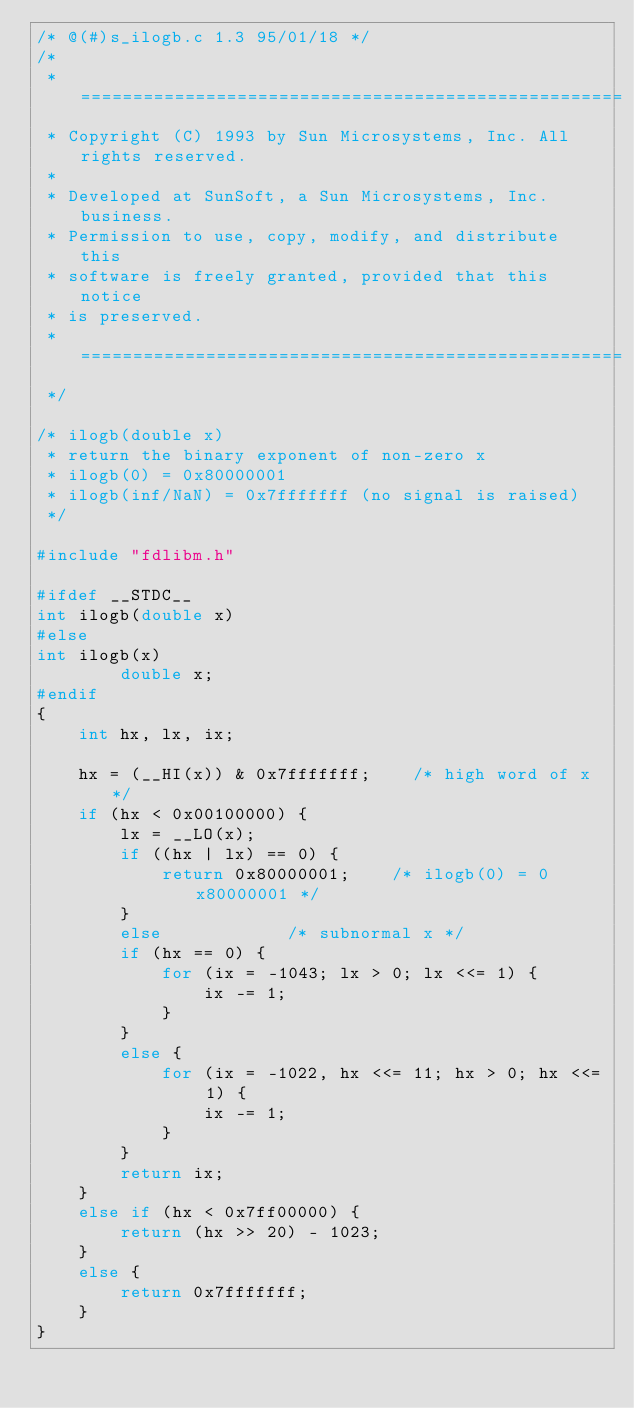Convert code to text. <code><loc_0><loc_0><loc_500><loc_500><_C_>/* @(#)s_ilogb.c 1.3 95/01/18 */
/*
 * ====================================================
 * Copyright (C) 1993 by Sun Microsystems, Inc. All rights reserved.
 *
 * Developed at SunSoft, a Sun Microsystems, Inc. business.
 * Permission to use, copy, modify, and distribute this
 * software is freely granted, provided that this notice 
 * is preserved.
 * ====================================================
 */

/* ilogb(double x)
 * return the binary exponent of non-zero x
 * ilogb(0) = 0x80000001
 * ilogb(inf/NaN) = 0x7fffffff (no signal is raised)
 */

#include "fdlibm.h"

#ifdef __STDC__
int ilogb(double x)
#else
int ilogb(x)
        double x;
#endif
{
    int hx, lx, ix;

    hx = (__HI(x)) & 0x7fffffff;    /* high word of x */
    if (hx < 0x00100000) {
        lx = __LO(x);
        if ((hx | lx) == 0) {
            return 0x80000001;    /* ilogb(0) = 0x80000001 */
        }
        else            /* subnormal x */
        if (hx == 0) {
            for (ix = -1043; lx > 0; lx <<= 1) {
                ix -= 1;
            }
        }
        else {
            for (ix = -1022, hx <<= 11; hx > 0; hx <<= 1) {
                ix -= 1;
            }
        }
        return ix;
    }
    else if (hx < 0x7ff00000) {
        return (hx >> 20) - 1023;
    }
    else {
        return 0x7fffffff;
    }
}
</code> 